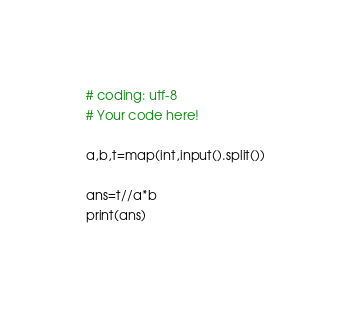Convert code to text. <code><loc_0><loc_0><loc_500><loc_500><_Python_># coding: utf-8
# Your code here!

a,b,t=map(int,input().split())

ans=t//a*b
print(ans)</code> 